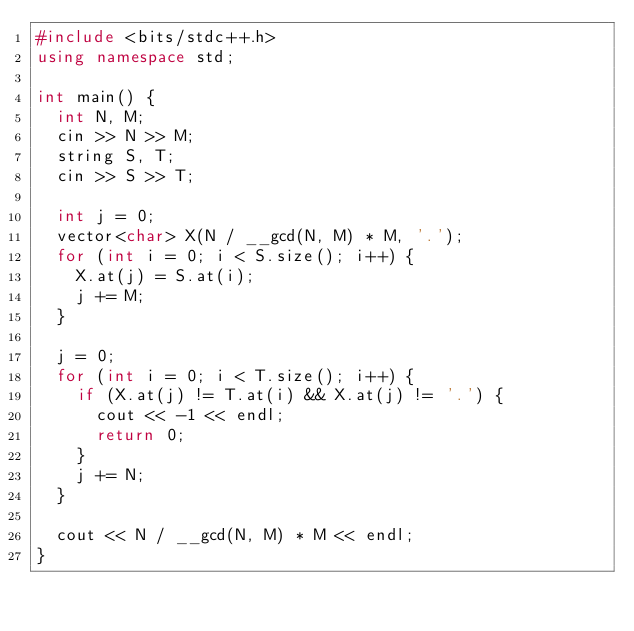<code> <loc_0><loc_0><loc_500><loc_500><_C++_>#include <bits/stdc++.h>
using namespace std;

int main() {
  int N, M;
  cin >> N >> M;
  string S, T;
  cin >> S >> T;

  int j = 0;
  vector<char> X(N / __gcd(N, M) * M, '.');
  for (int i = 0; i < S.size(); i++) {
    X.at(j) = S.at(i);
    j += M;
  }

  j = 0;
  for (int i = 0; i < T.size(); i++) {
    if (X.at(j) != T.at(i) && X.at(j) != '.') {
      cout << -1 << endl;
      return 0;
    }
    j += N;
  }

  cout << N / __gcd(N, M) * M << endl;
}
</code> 